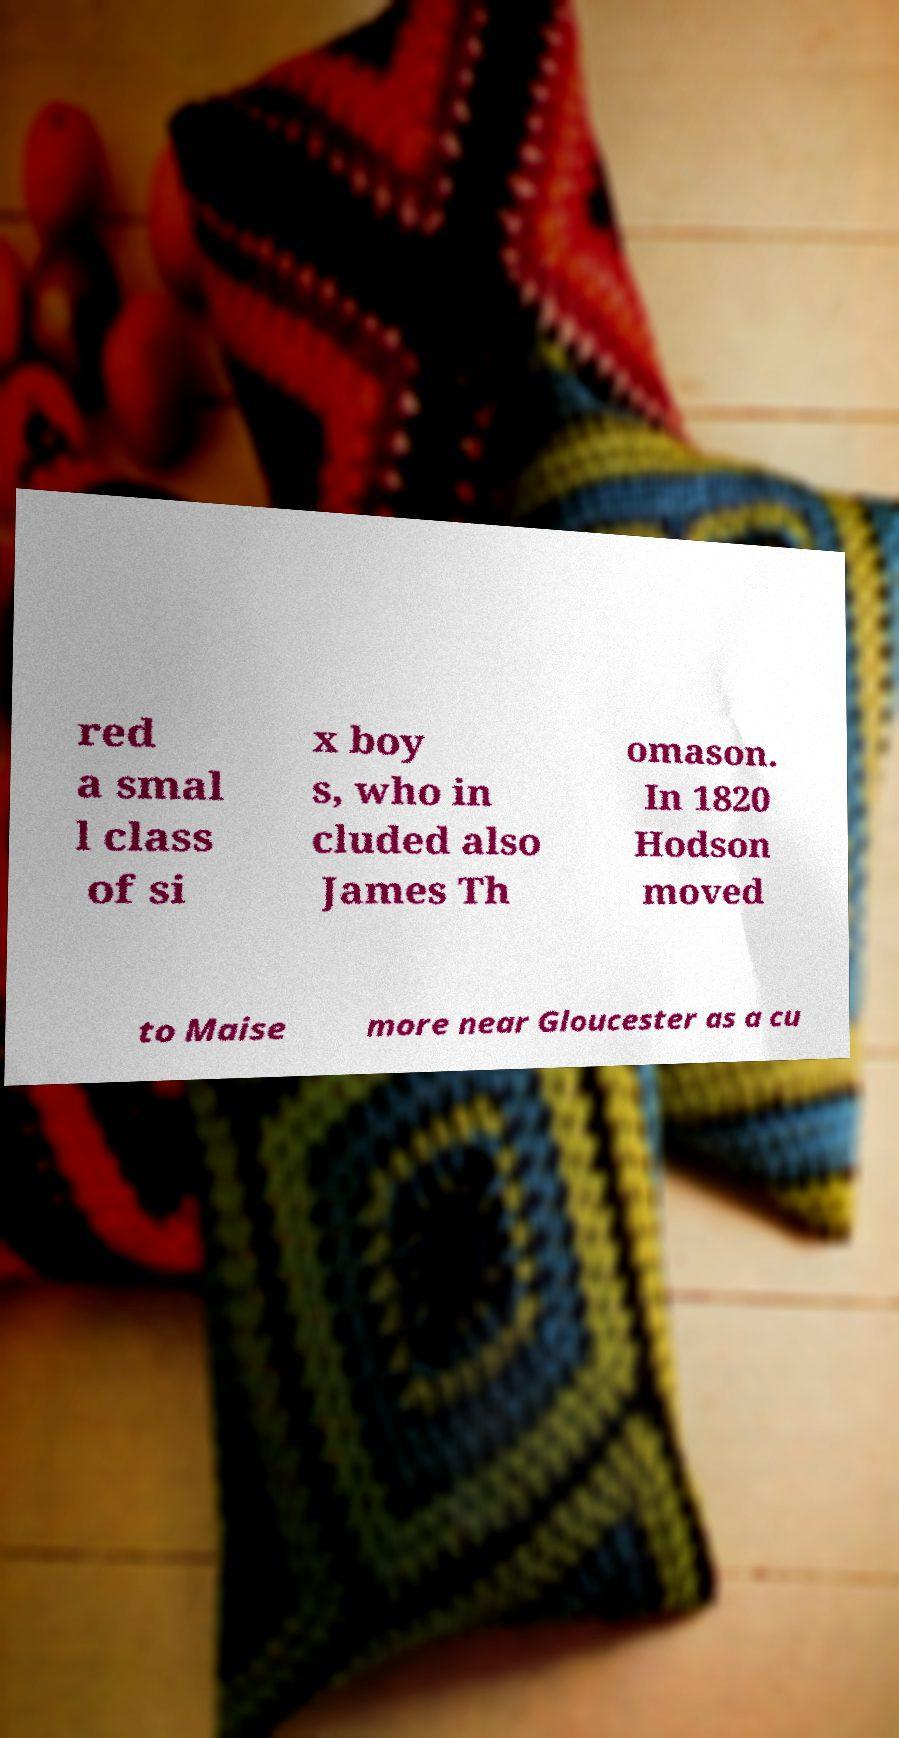Could you extract and type out the text from this image? red a smal l class of si x boy s, who in cluded also James Th omason. In 1820 Hodson moved to Maise more near Gloucester as a cu 